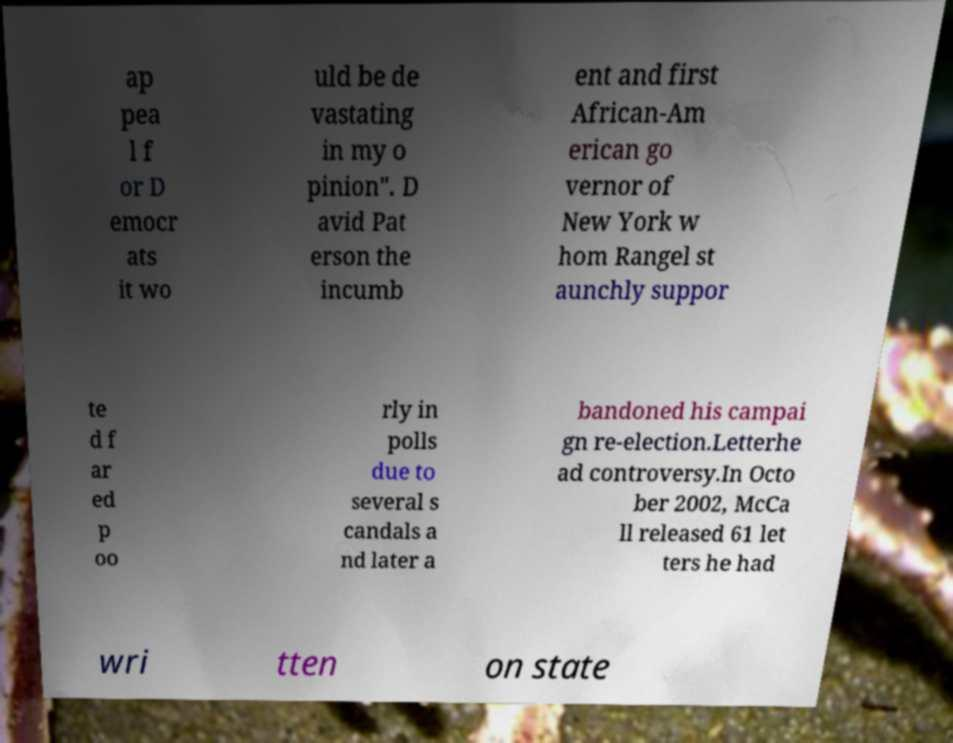What messages or text are displayed in this image? I need them in a readable, typed format. ap pea l f or D emocr ats it wo uld be de vastating in my o pinion". D avid Pat erson the incumb ent and first African-Am erican go vernor of New York w hom Rangel st aunchly suppor te d f ar ed p oo rly in polls due to several s candals a nd later a bandoned his campai gn re-election.Letterhe ad controversy.In Octo ber 2002, McCa ll released 61 let ters he had wri tten on state 